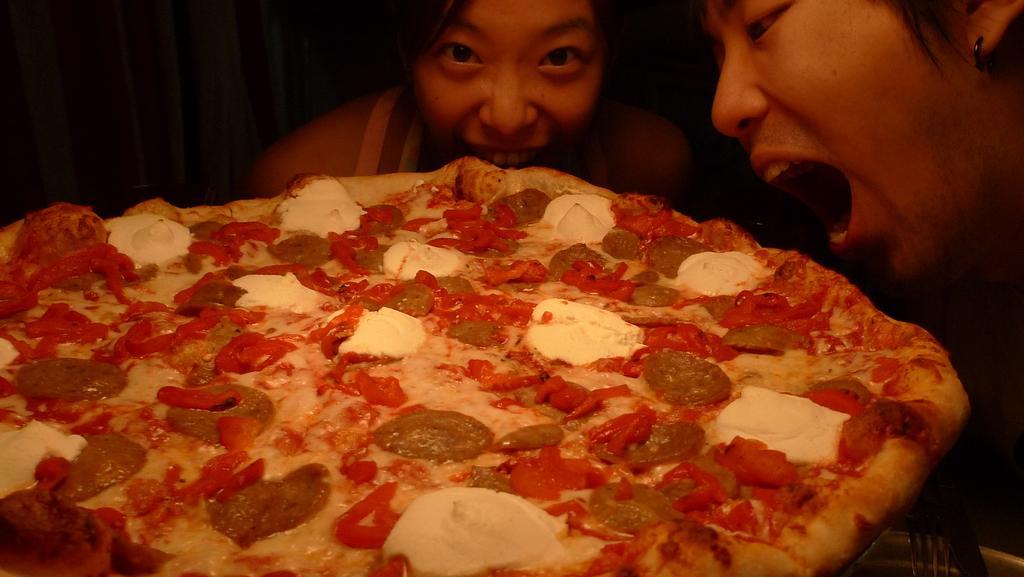In one or two sentences, can you explain what this image depicts? In this picture there are two women who are trying to eat the pizza. This pizza is kept on the table. On the top left corner I can see the darkness. 